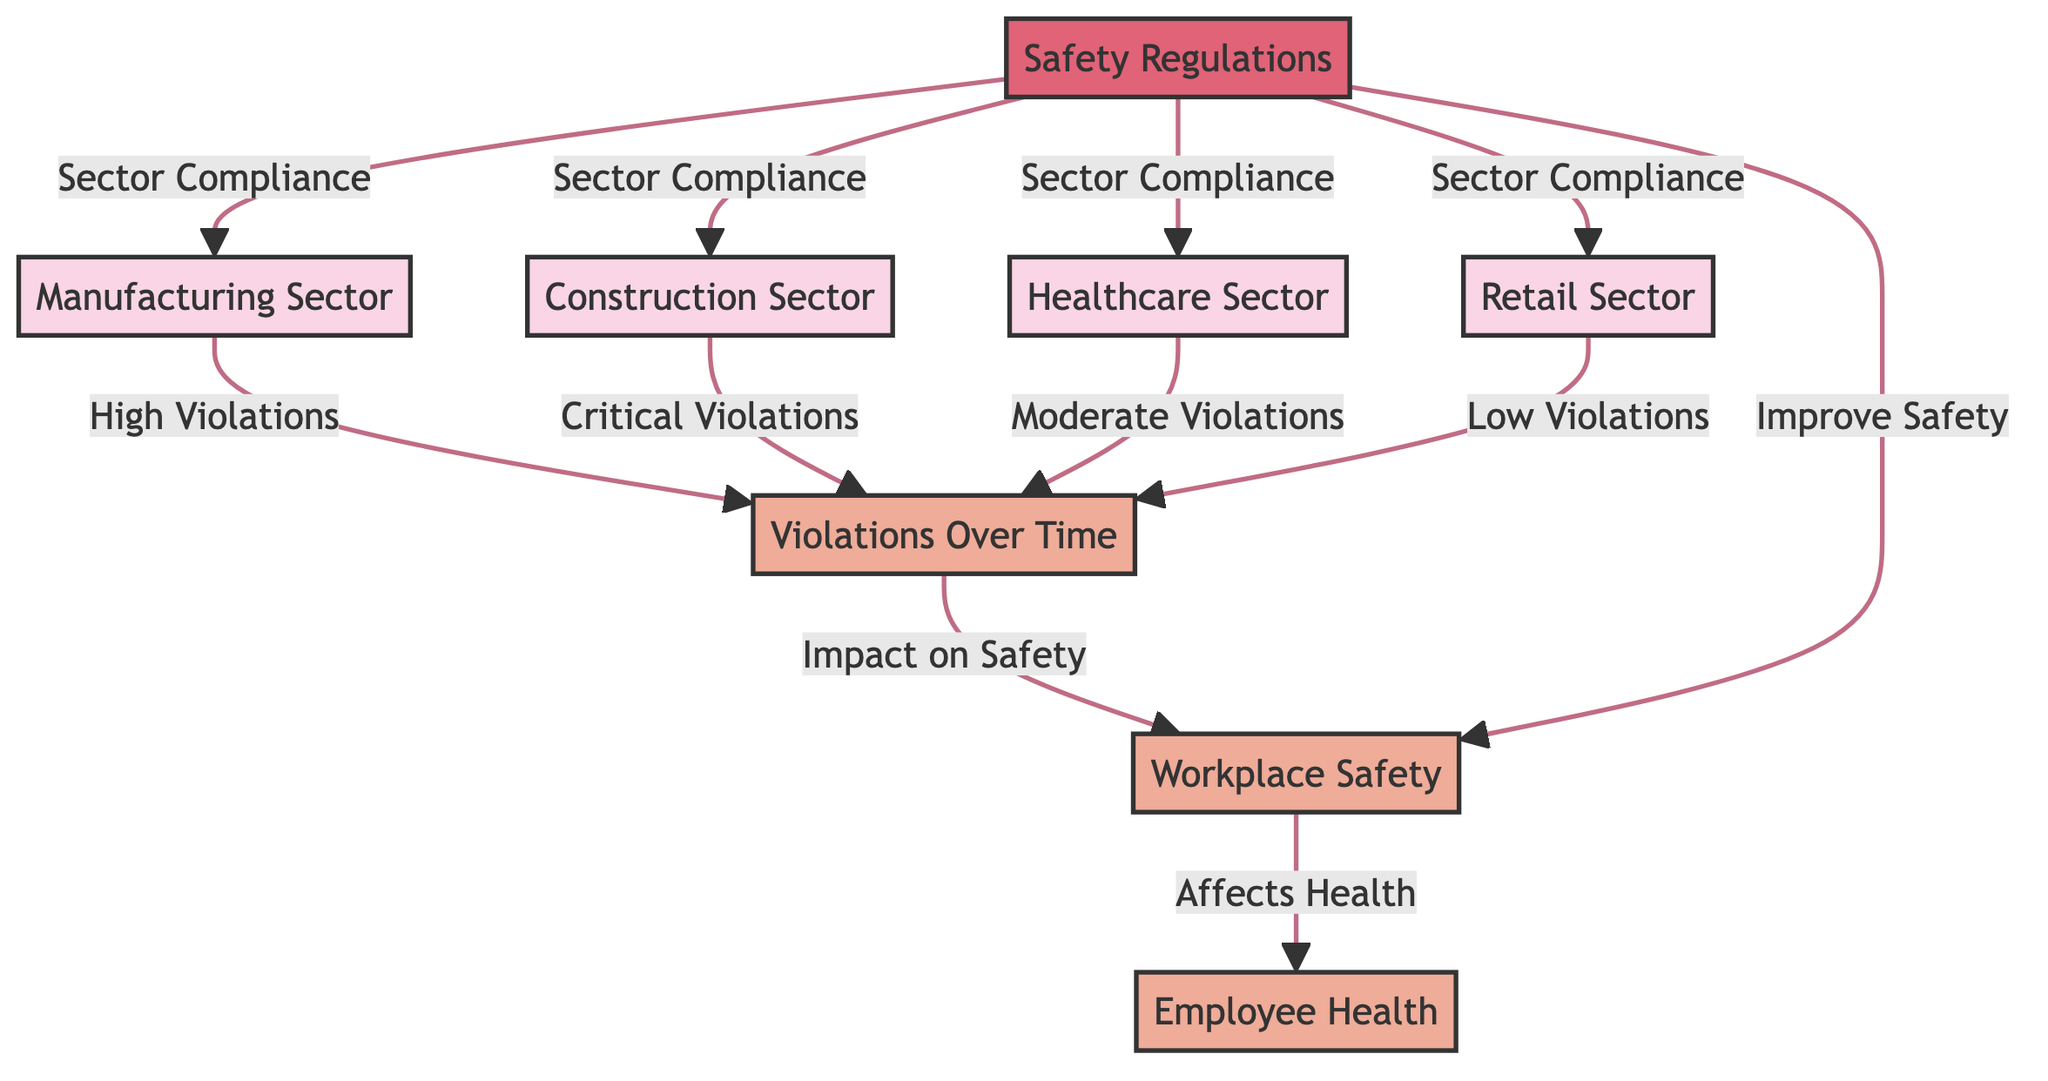what sectors are represented in the diagram? The diagram includes four sectors: Manufacturing, Construction, Healthcare, and Retail. Each sector is shown as a node connected to the violations over time node, indicating their relevance to workplace health and safety violations.
Answer: Manufacturing, Construction, Healthcare, Retail which sector has high violations? The Manufacturing Sector is indicated as having high violations, as it is directly connected to the violations over time node with a label specifying "High Violations."
Answer: High Violations how many sectors are impacted by safety regulations? All four sectors—Manufacturing, Construction, Healthcare, and Retail—are affected by safety regulations, each having a connection indicating "Sector Compliance" to the safety regulations node.
Answer: Four what type of violation is associated with the construction sector? The Construction Sector is described as having "Critical Violations," which is indicated by the specific label on the directed connection to the violations over time node.
Answer: Critical Violations what is the relationship between workplace safety and employee health? Workplace safety directly influences employee health, as the diagram shows a connection labeled "Affects Health" from the workplace safety node to the employee health node, indicating a clear causative relationship.
Answer: Affects Health what effect do safety regulations have on workplace safety? The safety regulations are shown to both improve safety and ensure sector compliance, which indicates that their enforcement is aimed at enhancing overall workplace safety standards across sectors.
Answer: Improve Safety which sector has low violations? The Retail Sector is mentioned as having low violations, as shown by its connection to the violations over time node labeled "Low Violations," distinguishing it from the other sectors.
Answer: Low Violations what type of diagram is this? The diagram is a flowchart, which visually represents the relationships and connections between employment sectors and violations over time regarding workplace health and safety.
Answer: Flowchart 